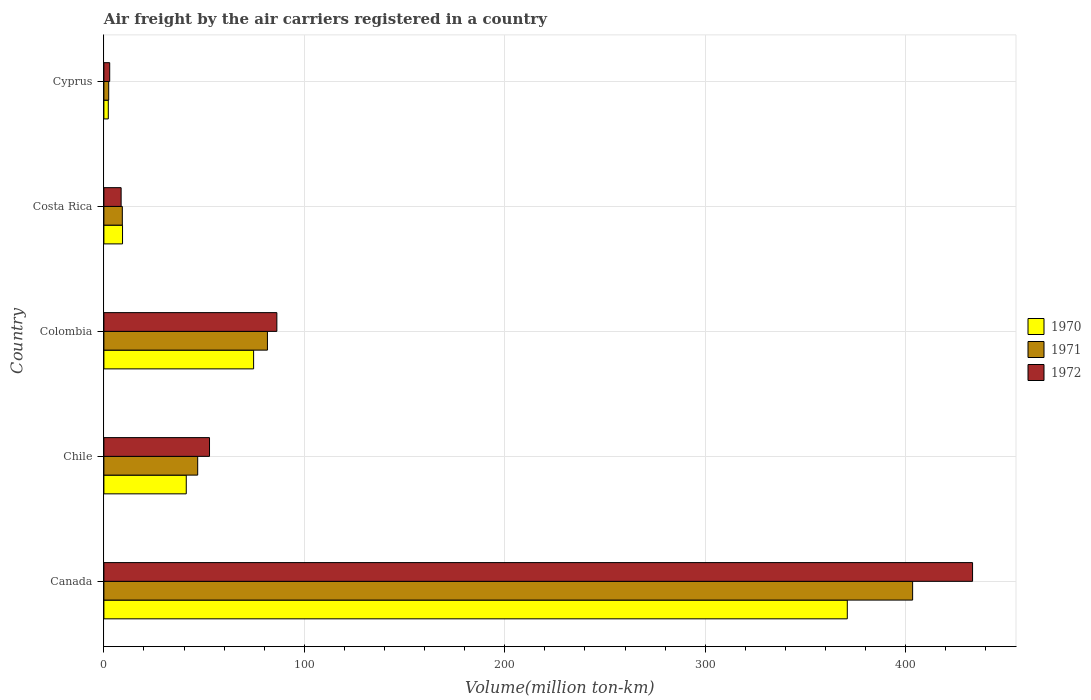How many different coloured bars are there?
Your response must be concise. 3. Are the number of bars per tick equal to the number of legend labels?
Keep it short and to the point. Yes. How many bars are there on the 4th tick from the bottom?
Keep it short and to the point. 3. What is the label of the 1st group of bars from the top?
Give a very brief answer. Cyprus. What is the volume of the air carriers in 1970 in Chile?
Offer a terse response. 41.1. Across all countries, what is the maximum volume of the air carriers in 1971?
Provide a succinct answer. 403.5. Across all countries, what is the minimum volume of the air carriers in 1971?
Offer a very short reply. 2.4. In which country was the volume of the air carriers in 1971 maximum?
Your answer should be compact. Canada. In which country was the volume of the air carriers in 1972 minimum?
Your answer should be very brief. Cyprus. What is the total volume of the air carriers in 1972 in the graph?
Offer a very short reply. 583.9. What is the difference between the volume of the air carriers in 1970 in Colombia and that in Costa Rica?
Your answer should be very brief. 65.4. What is the difference between the volume of the air carriers in 1970 in Cyprus and the volume of the air carriers in 1971 in Costa Rica?
Your answer should be very brief. -7. What is the average volume of the air carriers in 1971 per country?
Make the answer very short. 108.7. What is the difference between the volume of the air carriers in 1972 and volume of the air carriers in 1970 in Colombia?
Give a very brief answer. 11.6. What is the ratio of the volume of the air carriers in 1972 in Canada to that in Cyprus?
Make the answer very short. 149.45. What is the difference between the highest and the second highest volume of the air carriers in 1970?
Keep it short and to the point. 296.2. What is the difference between the highest and the lowest volume of the air carriers in 1971?
Your answer should be compact. 401.1. What does the 3rd bar from the top in Costa Rica represents?
Give a very brief answer. 1970. What does the 3rd bar from the bottom in Colombia represents?
Ensure brevity in your answer.  1972. Is it the case that in every country, the sum of the volume of the air carriers in 1971 and volume of the air carriers in 1970 is greater than the volume of the air carriers in 1972?
Your answer should be compact. Yes. How many bars are there?
Offer a very short reply. 15. Are all the bars in the graph horizontal?
Provide a short and direct response. Yes. What is the difference between two consecutive major ticks on the X-axis?
Give a very brief answer. 100. Are the values on the major ticks of X-axis written in scientific E-notation?
Your answer should be compact. No. Does the graph contain any zero values?
Give a very brief answer. No. Does the graph contain grids?
Make the answer very short. Yes. Where does the legend appear in the graph?
Keep it short and to the point. Center right. How are the legend labels stacked?
Keep it short and to the point. Vertical. What is the title of the graph?
Your answer should be very brief. Air freight by the air carriers registered in a country. Does "1996" appear as one of the legend labels in the graph?
Your answer should be compact. No. What is the label or title of the X-axis?
Provide a succinct answer. Volume(million ton-km). What is the Volume(million ton-km) in 1970 in Canada?
Offer a very short reply. 370.9. What is the Volume(million ton-km) in 1971 in Canada?
Your answer should be compact. 403.5. What is the Volume(million ton-km) in 1972 in Canada?
Your answer should be compact. 433.4. What is the Volume(million ton-km) of 1970 in Chile?
Ensure brevity in your answer.  41.1. What is the Volume(million ton-km) of 1971 in Chile?
Your answer should be compact. 46.8. What is the Volume(million ton-km) in 1972 in Chile?
Provide a short and direct response. 52.7. What is the Volume(million ton-km) in 1970 in Colombia?
Make the answer very short. 74.7. What is the Volume(million ton-km) of 1971 in Colombia?
Offer a very short reply. 81.6. What is the Volume(million ton-km) of 1972 in Colombia?
Offer a very short reply. 86.3. What is the Volume(million ton-km) in 1970 in Costa Rica?
Provide a short and direct response. 9.3. What is the Volume(million ton-km) of 1971 in Costa Rica?
Make the answer very short. 9.2. What is the Volume(million ton-km) of 1972 in Costa Rica?
Make the answer very short. 8.6. What is the Volume(million ton-km) in 1970 in Cyprus?
Your answer should be very brief. 2.2. What is the Volume(million ton-km) in 1971 in Cyprus?
Ensure brevity in your answer.  2.4. What is the Volume(million ton-km) of 1972 in Cyprus?
Your answer should be very brief. 2.9. Across all countries, what is the maximum Volume(million ton-km) of 1970?
Provide a succinct answer. 370.9. Across all countries, what is the maximum Volume(million ton-km) of 1971?
Your answer should be very brief. 403.5. Across all countries, what is the maximum Volume(million ton-km) in 1972?
Provide a short and direct response. 433.4. Across all countries, what is the minimum Volume(million ton-km) of 1970?
Offer a terse response. 2.2. Across all countries, what is the minimum Volume(million ton-km) of 1971?
Provide a succinct answer. 2.4. Across all countries, what is the minimum Volume(million ton-km) in 1972?
Make the answer very short. 2.9. What is the total Volume(million ton-km) of 1970 in the graph?
Ensure brevity in your answer.  498.2. What is the total Volume(million ton-km) in 1971 in the graph?
Your answer should be compact. 543.5. What is the total Volume(million ton-km) of 1972 in the graph?
Keep it short and to the point. 583.9. What is the difference between the Volume(million ton-km) of 1970 in Canada and that in Chile?
Ensure brevity in your answer.  329.8. What is the difference between the Volume(million ton-km) of 1971 in Canada and that in Chile?
Your answer should be very brief. 356.7. What is the difference between the Volume(million ton-km) of 1972 in Canada and that in Chile?
Offer a terse response. 380.7. What is the difference between the Volume(million ton-km) of 1970 in Canada and that in Colombia?
Your answer should be compact. 296.2. What is the difference between the Volume(million ton-km) of 1971 in Canada and that in Colombia?
Provide a short and direct response. 321.9. What is the difference between the Volume(million ton-km) in 1972 in Canada and that in Colombia?
Your response must be concise. 347.1. What is the difference between the Volume(million ton-km) of 1970 in Canada and that in Costa Rica?
Your response must be concise. 361.6. What is the difference between the Volume(million ton-km) of 1971 in Canada and that in Costa Rica?
Give a very brief answer. 394.3. What is the difference between the Volume(million ton-km) of 1972 in Canada and that in Costa Rica?
Your response must be concise. 424.8. What is the difference between the Volume(million ton-km) in 1970 in Canada and that in Cyprus?
Keep it short and to the point. 368.7. What is the difference between the Volume(million ton-km) in 1971 in Canada and that in Cyprus?
Your answer should be very brief. 401.1. What is the difference between the Volume(million ton-km) in 1972 in Canada and that in Cyprus?
Give a very brief answer. 430.5. What is the difference between the Volume(million ton-km) in 1970 in Chile and that in Colombia?
Provide a short and direct response. -33.6. What is the difference between the Volume(million ton-km) of 1971 in Chile and that in Colombia?
Offer a very short reply. -34.8. What is the difference between the Volume(million ton-km) of 1972 in Chile and that in Colombia?
Your answer should be very brief. -33.6. What is the difference between the Volume(million ton-km) of 1970 in Chile and that in Costa Rica?
Your answer should be very brief. 31.8. What is the difference between the Volume(million ton-km) of 1971 in Chile and that in Costa Rica?
Offer a terse response. 37.6. What is the difference between the Volume(million ton-km) of 1972 in Chile and that in Costa Rica?
Your answer should be compact. 44.1. What is the difference between the Volume(million ton-km) of 1970 in Chile and that in Cyprus?
Your answer should be very brief. 38.9. What is the difference between the Volume(million ton-km) of 1971 in Chile and that in Cyprus?
Provide a short and direct response. 44.4. What is the difference between the Volume(million ton-km) of 1972 in Chile and that in Cyprus?
Make the answer very short. 49.8. What is the difference between the Volume(million ton-km) in 1970 in Colombia and that in Costa Rica?
Offer a terse response. 65.4. What is the difference between the Volume(million ton-km) of 1971 in Colombia and that in Costa Rica?
Give a very brief answer. 72.4. What is the difference between the Volume(million ton-km) of 1972 in Colombia and that in Costa Rica?
Your answer should be very brief. 77.7. What is the difference between the Volume(million ton-km) in 1970 in Colombia and that in Cyprus?
Provide a short and direct response. 72.5. What is the difference between the Volume(million ton-km) of 1971 in Colombia and that in Cyprus?
Ensure brevity in your answer.  79.2. What is the difference between the Volume(million ton-km) in 1972 in Colombia and that in Cyprus?
Provide a succinct answer. 83.4. What is the difference between the Volume(million ton-km) in 1970 in Costa Rica and that in Cyprus?
Your answer should be compact. 7.1. What is the difference between the Volume(million ton-km) of 1971 in Costa Rica and that in Cyprus?
Your answer should be very brief. 6.8. What is the difference between the Volume(million ton-km) in 1970 in Canada and the Volume(million ton-km) in 1971 in Chile?
Provide a short and direct response. 324.1. What is the difference between the Volume(million ton-km) of 1970 in Canada and the Volume(million ton-km) of 1972 in Chile?
Make the answer very short. 318.2. What is the difference between the Volume(million ton-km) in 1971 in Canada and the Volume(million ton-km) in 1972 in Chile?
Provide a succinct answer. 350.8. What is the difference between the Volume(million ton-km) of 1970 in Canada and the Volume(million ton-km) of 1971 in Colombia?
Ensure brevity in your answer.  289.3. What is the difference between the Volume(million ton-km) of 1970 in Canada and the Volume(million ton-km) of 1972 in Colombia?
Give a very brief answer. 284.6. What is the difference between the Volume(million ton-km) of 1971 in Canada and the Volume(million ton-km) of 1972 in Colombia?
Ensure brevity in your answer.  317.2. What is the difference between the Volume(million ton-km) in 1970 in Canada and the Volume(million ton-km) in 1971 in Costa Rica?
Offer a terse response. 361.7. What is the difference between the Volume(million ton-km) in 1970 in Canada and the Volume(million ton-km) in 1972 in Costa Rica?
Give a very brief answer. 362.3. What is the difference between the Volume(million ton-km) of 1971 in Canada and the Volume(million ton-km) of 1972 in Costa Rica?
Your response must be concise. 394.9. What is the difference between the Volume(million ton-km) in 1970 in Canada and the Volume(million ton-km) in 1971 in Cyprus?
Make the answer very short. 368.5. What is the difference between the Volume(million ton-km) in 1970 in Canada and the Volume(million ton-km) in 1972 in Cyprus?
Your answer should be compact. 368. What is the difference between the Volume(million ton-km) of 1971 in Canada and the Volume(million ton-km) of 1972 in Cyprus?
Provide a succinct answer. 400.6. What is the difference between the Volume(million ton-km) of 1970 in Chile and the Volume(million ton-km) of 1971 in Colombia?
Keep it short and to the point. -40.5. What is the difference between the Volume(million ton-km) in 1970 in Chile and the Volume(million ton-km) in 1972 in Colombia?
Offer a very short reply. -45.2. What is the difference between the Volume(million ton-km) in 1971 in Chile and the Volume(million ton-km) in 1972 in Colombia?
Your response must be concise. -39.5. What is the difference between the Volume(million ton-km) in 1970 in Chile and the Volume(million ton-km) in 1971 in Costa Rica?
Your answer should be compact. 31.9. What is the difference between the Volume(million ton-km) in 1970 in Chile and the Volume(million ton-km) in 1972 in Costa Rica?
Make the answer very short. 32.5. What is the difference between the Volume(million ton-km) in 1971 in Chile and the Volume(million ton-km) in 1972 in Costa Rica?
Your response must be concise. 38.2. What is the difference between the Volume(million ton-km) in 1970 in Chile and the Volume(million ton-km) in 1971 in Cyprus?
Offer a very short reply. 38.7. What is the difference between the Volume(million ton-km) in 1970 in Chile and the Volume(million ton-km) in 1972 in Cyprus?
Your response must be concise. 38.2. What is the difference between the Volume(million ton-km) of 1971 in Chile and the Volume(million ton-km) of 1972 in Cyprus?
Ensure brevity in your answer.  43.9. What is the difference between the Volume(million ton-km) in 1970 in Colombia and the Volume(million ton-km) in 1971 in Costa Rica?
Your answer should be compact. 65.5. What is the difference between the Volume(million ton-km) in 1970 in Colombia and the Volume(million ton-km) in 1972 in Costa Rica?
Keep it short and to the point. 66.1. What is the difference between the Volume(million ton-km) in 1970 in Colombia and the Volume(million ton-km) in 1971 in Cyprus?
Keep it short and to the point. 72.3. What is the difference between the Volume(million ton-km) in 1970 in Colombia and the Volume(million ton-km) in 1972 in Cyprus?
Provide a short and direct response. 71.8. What is the difference between the Volume(million ton-km) of 1971 in Colombia and the Volume(million ton-km) of 1972 in Cyprus?
Your response must be concise. 78.7. What is the difference between the Volume(million ton-km) in 1970 in Costa Rica and the Volume(million ton-km) in 1971 in Cyprus?
Make the answer very short. 6.9. What is the difference between the Volume(million ton-km) in 1970 in Costa Rica and the Volume(million ton-km) in 1972 in Cyprus?
Your answer should be very brief. 6.4. What is the difference between the Volume(million ton-km) in 1971 in Costa Rica and the Volume(million ton-km) in 1972 in Cyprus?
Give a very brief answer. 6.3. What is the average Volume(million ton-km) of 1970 per country?
Provide a short and direct response. 99.64. What is the average Volume(million ton-km) in 1971 per country?
Offer a very short reply. 108.7. What is the average Volume(million ton-km) of 1972 per country?
Ensure brevity in your answer.  116.78. What is the difference between the Volume(million ton-km) of 1970 and Volume(million ton-km) of 1971 in Canada?
Your answer should be very brief. -32.6. What is the difference between the Volume(million ton-km) in 1970 and Volume(million ton-km) in 1972 in Canada?
Give a very brief answer. -62.5. What is the difference between the Volume(million ton-km) of 1971 and Volume(million ton-km) of 1972 in Canada?
Make the answer very short. -29.9. What is the difference between the Volume(million ton-km) in 1970 and Volume(million ton-km) in 1971 in Chile?
Give a very brief answer. -5.7. What is the difference between the Volume(million ton-km) in 1970 and Volume(million ton-km) in 1972 in Colombia?
Offer a very short reply. -11.6. What is the difference between the Volume(million ton-km) in 1970 and Volume(million ton-km) in 1971 in Costa Rica?
Make the answer very short. 0.1. What is the difference between the Volume(million ton-km) in 1970 and Volume(million ton-km) in 1972 in Costa Rica?
Ensure brevity in your answer.  0.7. What is the difference between the Volume(million ton-km) in 1971 and Volume(million ton-km) in 1972 in Cyprus?
Make the answer very short. -0.5. What is the ratio of the Volume(million ton-km) in 1970 in Canada to that in Chile?
Your response must be concise. 9.02. What is the ratio of the Volume(million ton-km) in 1971 in Canada to that in Chile?
Provide a short and direct response. 8.62. What is the ratio of the Volume(million ton-km) in 1972 in Canada to that in Chile?
Provide a short and direct response. 8.22. What is the ratio of the Volume(million ton-km) of 1970 in Canada to that in Colombia?
Your answer should be compact. 4.97. What is the ratio of the Volume(million ton-km) in 1971 in Canada to that in Colombia?
Offer a terse response. 4.94. What is the ratio of the Volume(million ton-km) in 1972 in Canada to that in Colombia?
Provide a short and direct response. 5.02. What is the ratio of the Volume(million ton-km) of 1970 in Canada to that in Costa Rica?
Offer a terse response. 39.88. What is the ratio of the Volume(million ton-km) in 1971 in Canada to that in Costa Rica?
Provide a succinct answer. 43.86. What is the ratio of the Volume(million ton-km) in 1972 in Canada to that in Costa Rica?
Make the answer very short. 50.4. What is the ratio of the Volume(million ton-km) of 1970 in Canada to that in Cyprus?
Your answer should be very brief. 168.59. What is the ratio of the Volume(million ton-km) in 1971 in Canada to that in Cyprus?
Provide a succinct answer. 168.12. What is the ratio of the Volume(million ton-km) in 1972 in Canada to that in Cyprus?
Your answer should be compact. 149.45. What is the ratio of the Volume(million ton-km) of 1970 in Chile to that in Colombia?
Ensure brevity in your answer.  0.55. What is the ratio of the Volume(million ton-km) in 1971 in Chile to that in Colombia?
Offer a terse response. 0.57. What is the ratio of the Volume(million ton-km) of 1972 in Chile to that in Colombia?
Offer a terse response. 0.61. What is the ratio of the Volume(million ton-km) of 1970 in Chile to that in Costa Rica?
Offer a very short reply. 4.42. What is the ratio of the Volume(million ton-km) in 1971 in Chile to that in Costa Rica?
Keep it short and to the point. 5.09. What is the ratio of the Volume(million ton-km) of 1972 in Chile to that in Costa Rica?
Make the answer very short. 6.13. What is the ratio of the Volume(million ton-km) in 1970 in Chile to that in Cyprus?
Ensure brevity in your answer.  18.68. What is the ratio of the Volume(million ton-km) in 1971 in Chile to that in Cyprus?
Ensure brevity in your answer.  19.5. What is the ratio of the Volume(million ton-km) of 1972 in Chile to that in Cyprus?
Offer a terse response. 18.17. What is the ratio of the Volume(million ton-km) of 1970 in Colombia to that in Costa Rica?
Provide a succinct answer. 8.03. What is the ratio of the Volume(million ton-km) of 1971 in Colombia to that in Costa Rica?
Your answer should be very brief. 8.87. What is the ratio of the Volume(million ton-km) in 1972 in Colombia to that in Costa Rica?
Ensure brevity in your answer.  10.03. What is the ratio of the Volume(million ton-km) in 1970 in Colombia to that in Cyprus?
Offer a terse response. 33.95. What is the ratio of the Volume(million ton-km) in 1971 in Colombia to that in Cyprus?
Your answer should be very brief. 34. What is the ratio of the Volume(million ton-km) of 1972 in Colombia to that in Cyprus?
Provide a short and direct response. 29.76. What is the ratio of the Volume(million ton-km) of 1970 in Costa Rica to that in Cyprus?
Keep it short and to the point. 4.23. What is the ratio of the Volume(million ton-km) of 1971 in Costa Rica to that in Cyprus?
Give a very brief answer. 3.83. What is the ratio of the Volume(million ton-km) in 1972 in Costa Rica to that in Cyprus?
Provide a succinct answer. 2.97. What is the difference between the highest and the second highest Volume(million ton-km) of 1970?
Provide a short and direct response. 296.2. What is the difference between the highest and the second highest Volume(million ton-km) in 1971?
Keep it short and to the point. 321.9. What is the difference between the highest and the second highest Volume(million ton-km) of 1972?
Keep it short and to the point. 347.1. What is the difference between the highest and the lowest Volume(million ton-km) in 1970?
Offer a very short reply. 368.7. What is the difference between the highest and the lowest Volume(million ton-km) of 1971?
Provide a short and direct response. 401.1. What is the difference between the highest and the lowest Volume(million ton-km) of 1972?
Provide a succinct answer. 430.5. 